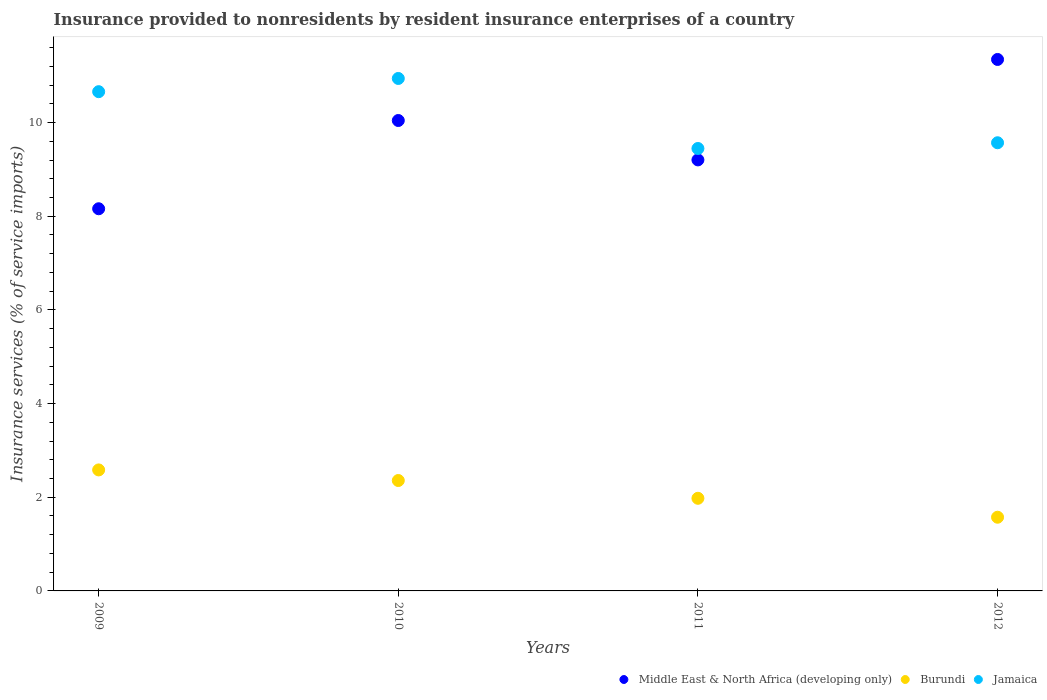How many different coloured dotlines are there?
Your answer should be compact. 3. Is the number of dotlines equal to the number of legend labels?
Give a very brief answer. Yes. What is the insurance provided to nonresidents in Middle East & North Africa (developing only) in 2010?
Provide a succinct answer. 10.04. Across all years, what is the maximum insurance provided to nonresidents in Jamaica?
Provide a succinct answer. 10.94. Across all years, what is the minimum insurance provided to nonresidents in Middle East & North Africa (developing only)?
Make the answer very short. 8.16. In which year was the insurance provided to nonresidents in Burundi maximum?
Offer a very short reply. 2009. In which year was the insurance provided to nonresidents in Jamaica minimum?
Give a very brief answer. 2011. What is the total insurance provided to nonresidents in Burundi in the graph?
Provide a short and direct response. 8.49. What is the difference between the insurance provided to nonresidents in Burundi in 2009 and that in 2011?
Offer a very short reply. 0.61. What is the difference between the insurance provided to nonresidents in Burundi in 2009 and the insurance provided to nonresidents in Jamaica in 2010?
Provide a succinct answer. -8.36. What is the average insurance provided to nonresidents in Middle East & North Africa (developing only) per year?
Make the answer very short. 9.69. In the year 2010, what is the difference between the insurance provided to nonresidents in Jamaica and insurance provided to nonresidents in Middle East & North Africa (developing only)?
Make the answer very short. 0.9. What is the ratio of the insurance provided to nonresidents in Jamaica in 2009 to that in 2010?
Make the answer very short. 0.97. Is the difference between the insurance provided to nonresidents in Jamaica in 2009 and 2011 greater than the difference between the insurance provided to nonresidents in Middle East & North Africa (developing only) in 2009 and 2011?
Provide a short and direct response. Yes. What is the difference between the highest and the second highest insurance provided to nonresidents in Jamaica?
Keep it short and to the point. 0.28. What is the difference between the highest and the lowest insurance provided to nonresidents in Burundi?
Offer a terse response. 1.01. In how many years, is the insurance provided to nonresidents in Middle East & North Africa (developing only) greater than the average insurance provided to nonresidents in Middle East & North Africa (developing only) taken over all years?
Make the answer very short. 2. Is the sum of the insurance provided to nonresidents in Jamaica in 2011 and 2012 greater than the maximum insurance provided to nonresidents in Middle East & North Africa (developing only) across all years?
Your response must be concise. Yes. Is the insurance provided to nonresidents in Burundi strictly greater than the insurance provided to nonresidents in Jamaica over the years?
Provide a succinct answer. No. How many dotlines are there?
Provide a short and direct response. 3. How many years are there in the graph?
Your response must be concise. 4. What is the difference between two consecutive major ticks on the Y-axis?
Keep it short and to the point. 2. Are the values on the major ticks of Y-axis written in scientific E-notation?
Give a very brief answer. No. Does the graph contain grids?
Offer a terse response. No. Where does the legend appear in the graph?
Offer a terse response. Bottom right. How are the legend labels stacked?
Provide a succinct answer. Horizontal. What is the title of the graph?
Make the answer very short. Insurance provided to nonresidents by resident insurance enterprises of a country. Does "Samoa" appear as one of the legend labels in the graph?
Offer a very short reply. No. What is the label or title of the Y-axis?
Keep it short and to the point. Insurance services (% of service imports). What is the Insurance services (% of service imports) in Middle East & North Africa (developing only) in 2009?
Provide a succinct answer. 8.16. What is the Insurance services (% of service imports) of Burundi in 2009?
Provide a succinct answer. 2.58. What is the Insurance services (% of service imports) in Jamaica in 2009?
Provide a short and direct response. 10.66. What is the Insurance services (% of service imports) in Middle East & North Africa (developing only) in 2010?
Make the answer very short. 10.04. What is the Insurance services (% of service imports) of Burundi in 2010?
Make the answer very short. 2.36. What is the Insurance services (% of service imports) of Jamaica in 2010?
Your answer should be very brief. 10.94. What is the Insurance services (% of service imports) of Middle East & North Africa (developing only) in 2011?
Your answer should be compact. 9.2. What is the Insurance services (% of service imports) of Burundi in 2011?
Provide a succinct answer. 1.98. What is the Insurance services (% of service imports) of Jamaica in 2011?
Give a very brief answer. 9.45. What is the Insurance services (% of service imports) in Middle East & North Africa (developing only) in 2012?
Provide a short and direct response. 11.35. What is the Insurance services (% of service imports) in Burundi in 2012?
Your answer should be compact. 1.57. What is the Insurance services (% of service imports) in Jamaica in 2012?
Your answer should be compact. 9.57. Across all years, what is the maximum Insurance services (% of service imports) in Middle East & North Africa (developing only)?
Your answer should be very brief. 11.35. Across all years, what is the maximum Insurance services (% of service imports) in Burundi?
Keep it short and to the point. 2.58. Across all years, what is the maximum Insurance services (% of service imports) of Jamaica?
Provide a succinct answer. 10.94. Across all years, what is the minimum Insurance services (% of service imports) of Middle East & North Africa (developing only)?
Keep it short and to the point. 8.16. Across all years, what is the minimum Insurance services (% of service imports) of Burundi?
Make the answer very short. 1.57. Across all years, what is the minimum Insurance services (% of service imports) in Jamaica?
Your answer should be very brief. 9.45. What is the total Insurance services (% of service imports) of Middle East & North Africa (developing only) in the graph?
Keep it short and to the point. 38.76. What is the total Insurance services (% of service imports) in Burundi in the graph?
Provide a succinct answer. 8.49. What is the total Insurance services (% of service imports) of Jamaica in the graph?
Offer a terse response. 40.62. What is the difference between the Insurance services (% of service imports) of Middle East & North Africa (developing only) in 2009 and that in 2010?
Your response must be concise. -1.88. What is the difference between the Insurance services (% of service imports) in Burundi in 2009 and that in 2010?
Your response must be concise. 0.23. What is the difference between the Insurance services (% of service imports) of Jamaica in 2009 and that in 2010?
Give a very brief answer. -0.28. What is the difference between the Insurance services (% of service imports) of Middle East & North Africa (developing only) in 2009 and that in 2011?
Give a very brief answer. -1.04. What is the difference between the Insurance services (% of service imports) of Burundi in 2009 and that in 2011?
Your answer should be very brief. 0.61. What is the difference between the Insurance services (% of service imports) in Jamaica in 2009 and that in 2011?
Your answer should be very brief. 1.21. What is the difference between the Insurance services (% of service imports) in Middle East & North Africa (developing only) in 2009 and that in 2012?
Ensure brevity in your answer.  -3.19. What is the difference between the Insurance services (% of service imports) in Burundi in 2009 and that in 2012?
Your response must be concise. 1.01. What is the difference between the Insurance services (% of service imports) of Jamaica in 2009 and that in 2012?
Your answer should be very brief. 1.09. What is the difference between the Insurance services (% of service imports) in Middle East & North Africa (developing only) in 2010 and that in 2011?
Offer a terse response. 0.84. What is the difference between the Insurance services (% of service imports) in Burundi in 2010 and that in 2011?
Ensure brevity in your answer.  0.38. What is the difference between the Insurance services (% of service imports) in Jamaica in 2010 and that in 2011?
Your answer should be very brief. 1.5. What is the difference between the Insurance services (% of service imports) of Middle East & North Africa (developing only) in 2010 and that in 2012?
Keep it short and to the point. -1.3. What is the difference between the Insurance services (% of service imports) of Burundi in 2010 and that in 2012?
Ensure brevity in your answer.  0.78. What is the difference between the Insurance services (% of service imports) in Jamaica in 2010 and that in 2012?
Your answer should be compact. 1.37. What is the difference between the Insurance services (% of service imports) of Middle East & North Africa (developing only) in 2011 and that in 2012?
Keep it short and to the point. -2.14. What is the difference between the Insurance services (% of service imports) of Burundi in 2011 and that in 2012?
Make the answer very short. 0.4. What is the difference between the Insurance services (% of service imports) in Jamaica in 2011 and that in 2012?
Make the answer very short. -0.12. What is the difference between the Insurance services (% of service imports) in Middle East & North Africa (developing only) in 2009 and the Insurance services (% of service imports) in Burundi in 2010?
Provide a short and direct response. 5.8. What is the difference between the Insurance services (% of service imports) of Middle East & North Africa (developing only) in 2009 and the Insurance services (% of service imports) of Jamaica in 2010?
Provide a succinct answer. -2.78. What is the difference between the Insurance services (% of service imports) in Burundi in 2009 and the Insurance services (% of service imports) in Jamaica in 2010?
Offer a very short reply. -8.36. What is the difference between the Insurance services (% of service imports) of Middle East & North Africa (developing only) in 2009 and the Insurance services (% of service imports) of Burundi in 2011?
Provide a short and direct response. 6.18. What is the difference between the Insurance services (% of service imports) in Middle East & North Africa (developing only) in 2009 and the Insurance services (% of service imports) in Jamaica in 2011?
Keep it short and to the point. -1.29. What is the difference between the Insurance services (% of service imports) of Burundi in 2009 and the Insurance services (% of service imports) of Jamaica in 2011?
Your response must be concise. -6.86. What is the difference between the Insurance services (% of service imports) in Middle East & North Africa (developing only) in 2009 and the Insurance services (% of service imports) in Burundi in 2012?
Keep it short and to the point. 6.59. What is the difference between the Insurance services (% of service imports) of Middle East & North Africa (developing only) in 2009 and the Insurance services (% of service imports) of Jamaica in 2012?
Your answer should be compact. -1.41. What is the difference between the Insurance services (% of service imports) in Burundi in 2009 and the Insurance services (% of service imports) in Jamaica in 2012?
Ensure brevity in your answer.  -6.99. What is the difference between the Insurance services (% of service imports) in Middle East & North Africa (developing only) in 2010 and the Insurance services (% of service imports) in Burundi in 2011?
Your answer should be very brief. 8.07. What is the difference between the Insurance services (% of service imports) in Middle East & North Africa (developing only) in 2010 and the Insurance services (% of service imports) in Jamaica in 2011?
Offer a terse response. 0.6. What is the difference between the Insurance services (% of service imports) of Burundi in 2010 and the Insurance services (% of service imports) of Jamaica in 2011?
Offer a very short reply. -7.09. What is the difference between the Insurance services (% of service imports) of Middle East & North Africa (developing only) in 2010 and the Insurance services (% of service imports) of Burundi in 2012?
Provide a short and direct response. 8.47. What is the difference between the Insurance services (% of service imports) of Middle East & North Africa (developing only) in 2010 and the Insurance services (% of service imports) of Jamaica in 2012?
Offer a very short reply. 0.48. What is the difference between the Insurance services (% of service imports) of Burundi in 2010 and the Insurance services (% of service imports) of Jamaica in 2012?
Provide a short and direct response. -7.21. What is the difference between the Insurance services (% of service imports) of Middle East & North Africa (developing only) in 2011 and the Insurance services (% of service imports) of Burundi in 2012?
Make the answer very short. 7.63. What is the difference between the Insurance services (% of service imports) of Middle East & North Africa (developing only) in 2011 and the Insurance services (% of service imports) of Jamaica in 2012?
Make the answer very short. -0.37. What is the difference between the Insurance services (% of service imports) of Burundi in 2011 and the Insurance services (% of service imports) of Jamaica in 2012?
Offer a very short reply. -7.59. What is the average Insurance services (% of service imports) of Middle East & North Africa (developing only) per year?
Offer a terse response. 9.69. What is the average Insurance services (% of service imports) of Burundi per year?
Your answer should be very brief. 2.12. What is the average Insurance services (% of service imports) of Jamaica per year?
Give a very brief answer. 10.15. In the year 2009, what is the difference between the Insurance services (% of service imports) of Middle East & North Africa (developing only) and Insurance services (% of service imports) of Burundi?
Provide a succinct answer. 5.58. In the year 2009, what is the difference between the Insurance services (% of service imports) in Middle East & North Africa (developing only) and Insurance services (% of service imports) in Jamaica?
Your response must be concise. -2.5. In the year 2009, what is the difference between the Insurance services (% of service imports) of Burundi and Insurance services (% of service imports) of Jamaica?
Provide a succinct answer. -8.08. In the year 2010, what is the difference between the Insurance services (% of service imports) of Middle East & North Africa (developing only) and Insurance services (% of service imports) of Burundi?
Ensure brevity in your answer.  7.69. In the year 2010, what is the difference between the Insurance services (% of service imports) of Middle East & North Africa (developing only) and Insurance services (% of service imports) of Jamaica?
Your answer should be compact. -0.9. In the year 2010, what is the difference between the Insurance services (% of service imports) in Burundi and Insurance services (% of service imports) in Jamaica?
Keep it short and to the point. -8.58. In the year 2011, what is the difference between the Insurance services (% of service imports) in Middle East & North Africa (developing only) and Insurance services (% of service imports) in Burundi?
Provide a short and direct response. 7.23. In the year 2011, what is the difference between the Insurance services (% of service imports) in Middle East & North Africa (developing only) and Insurance services (% of service imports) in Jamaica?
Provide a succinct answer. -0.24. In the year 2011, what is the difference between the Insurance services (% of service imports) of Burundi and Insurance services (% of service imports) of Jamaica?
Provide a succinct answer. -7.47. In the year 2012, what is the difference between the Insurance services (% of service imports) in Middle East & North Africa (developing only) and Insurance services (% of service imports) in Burundi?
Give a very brief answer. 9.77. In the year 2012, what is the difference between the Insurance services (% of service imports) of Middle East & North Africa (developing only) and Insurance services (% of service imports) of Jamaica?
Make the answer very short. 1.78. In the year 2012, what is the difference between the Insurance services (% of service imports) in Burundi and Insurance services (% of service imports) in Jamaica?
Provide a succinct answer. -8. What is the ratio of the Insurance services (% of service imports) of Middle East & North Africa (developing only) in 2009 to that in 2010?
Your response must be concise. 0.81. What is the ratio of the Insurance services (% of service imports) of Burundi in 2009 to that in 2010?
Make the answer very short. 1.1. What is the ratio of the Insurance services (% of service imports) in Jamaica in 2009 to that in 2010?
Ensure brevity in your answer.  0.97. What is the ratio of the Insurance services (% of service imports) in Middle East & North Africa (developing only) in 2009 to that in 2011?
Offer a terse response. 0.89. What is the ratio of the Insurance services (% of service imports) in Burundi in 2009 to that in 2011?
Your response must be concise. 1.31. What is the ratio of the Insurance services (% of service imports) of Jamaica in 2009 to that in 2011?
Offer a very short reply. 1.13. What is the ratio of the Insurance services (% of service imports) in Middle East & North Africa (developing only) in 2009 to that in 2012?
Your response must be concise. 0.72. What is the ratio of the Insurance services (% of service imports) of Burundi in 2009 to that in 2012?
Offer a terse response. 1.64. What is the ratio of the Insurance services (% of service imports) of Jamaica in 2009 to that in 2012?
Your answer should be compact. 1.11. What is the ratio of the Insurance services (% of service imports) in Middle East & North Africa (developing only) in 2010 to that in 2011?
Give a very brief answer. 1.09. What is the ratio of the Insurance services (% of service imports) of Burundi in 2010 to that in 2011?
Give a very brief answer. 1.19. What is the ratio of the Insurance services (% of service imports) of Jamaica in 2010 to that in 2011?
Your response must be concise. 1.16. What is the ratio of the Insurance services (% of service imports) in Middle East & North Africa (developing only) in 2010 to that in 2012?
Your answer should be compact. 0.89. What is the ratio of the Insurance services (% of service imports) in Burundi in 2010 to that in 2012?
Your response must be concise. 1.5. What is the ratio of the Insurance services (% of service imports) in Jamaica in 2010 to that in 2012?
Your answer should be compact. 1.14. What is the ratio of the Insurance services (% of service imports) in Middle East & North Africa (developing only) in 2011 to that in 2012?
Make the answer very short. 0.81. What is the ratio of the Insurance services (% of service imports) of Burundi in 2011 to that in 2012?
Keep it short and to the point. 1.26. What is the ratio of the Insurance services (% of service imports) of Jamaica in 2011 to that in 2012?
Give a very brief answer. 0.99. What is the difference between the highest and the second highest Insurance services (% of service imports) of Middle East & North Africa (developing only)?
Provide a succinct answer. 1.3. What is the difference between the highest and the second highest Insurance services (% of service imports) of Burundi?
Provide a succinct answer. 0.23. What is the difference between the highest and the second highest Insurance services (% of service imports) of Jamaica?
Give a very brief answer. 0.28. What is the difference between the highest and the lowest Insurance services (% of service imports) of Middle East & North Africa (developing only)?
Your response must be concise. 3.19. What is the difference between the highest and the lowest Insurance services (% of service imports) in Burundi?
Your answer should be very brief. 1.01. What is the difference between the highest and the lowest Insurance services (% of service imports) in Jamaica?
Keep it short and to the point. 1.5. 